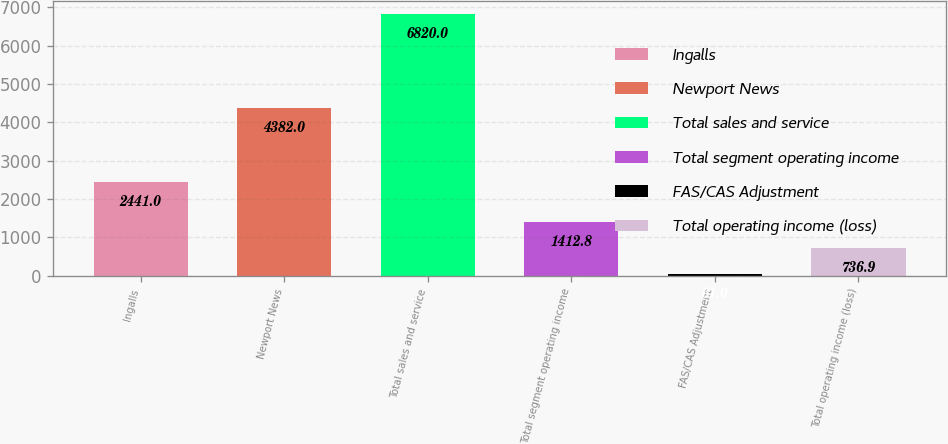<chart> <loc_0><loc_0><loc_500><loc_500><bar_chart><fcel>Ingalls<fcel>Newport News<fcel>Total sales and service<fcel>Total segment operating income<fcel>FAS/CAS Adjustment<fcel>Total operating income (loss)<nl><fcel>2441<fcel>4382<fcel>6820<fcel>1412.8<fcel>61<fcel>736.9<nl></chart> 